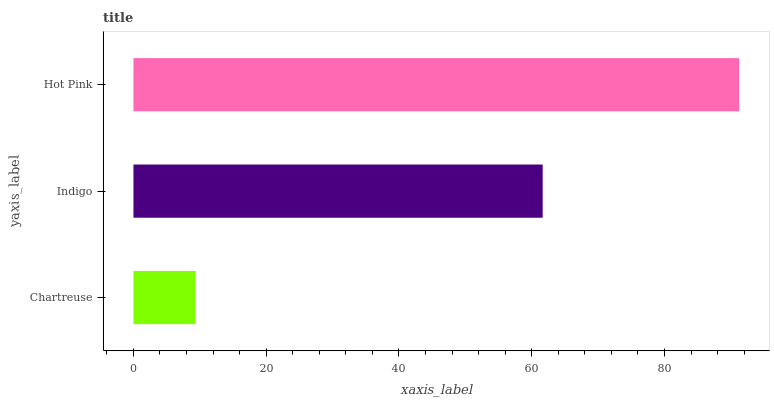Is Chartreuse the minimum?
Answer yes or no. Yes. Is Hot Pink the maximum?
Answer yes or no. Yes. Is Indigo the minimum?
Answer yes or no. No. Is Indigo the maximum?
Answer yes or no. No. Is Indigo greater than Chartreuse?
Answer yes or no. Yes. Is Chartreuse less than Indigo?
Answer yes or no. Yes. Is Chartreuse greater than Indigo?
Answer yes or no. No. Is Indigo less than Chartreuse?
Answer yes or no. No. Is Indigo the high median?
Answer yes or no. Yes. Is Indigo the low median?
Answer yes or no. Yes. Is Hot Pink the high median?
Answer yes or no. No. Is Chartreuse the low median?
Answer yes or no. No. 